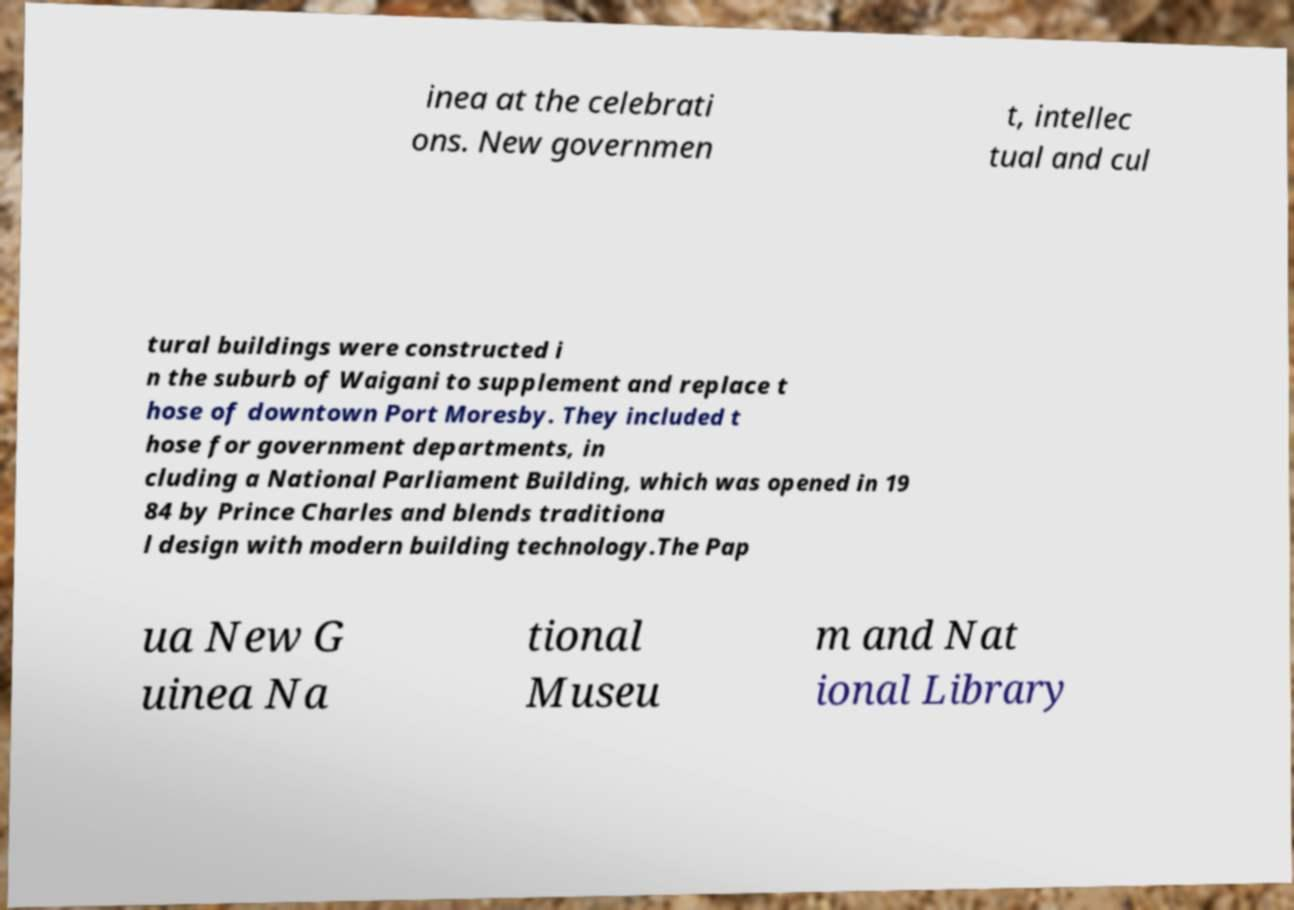Please identify and transcribe the text found in this image. inea at the celebrati ons. New governmen t, intellec tual and cul tural buildings were constructed i n the suburb of Waigani to supplement and replace t hose of downtown Port Moresby. They included t hose for government departments, in cluding a National Parliament Building, which was opened in 19 84 by Prince Charles and blends traditiona l design with modern building technology.The Pap ua New G uinea Na tional Museu m and Nat ional Library 